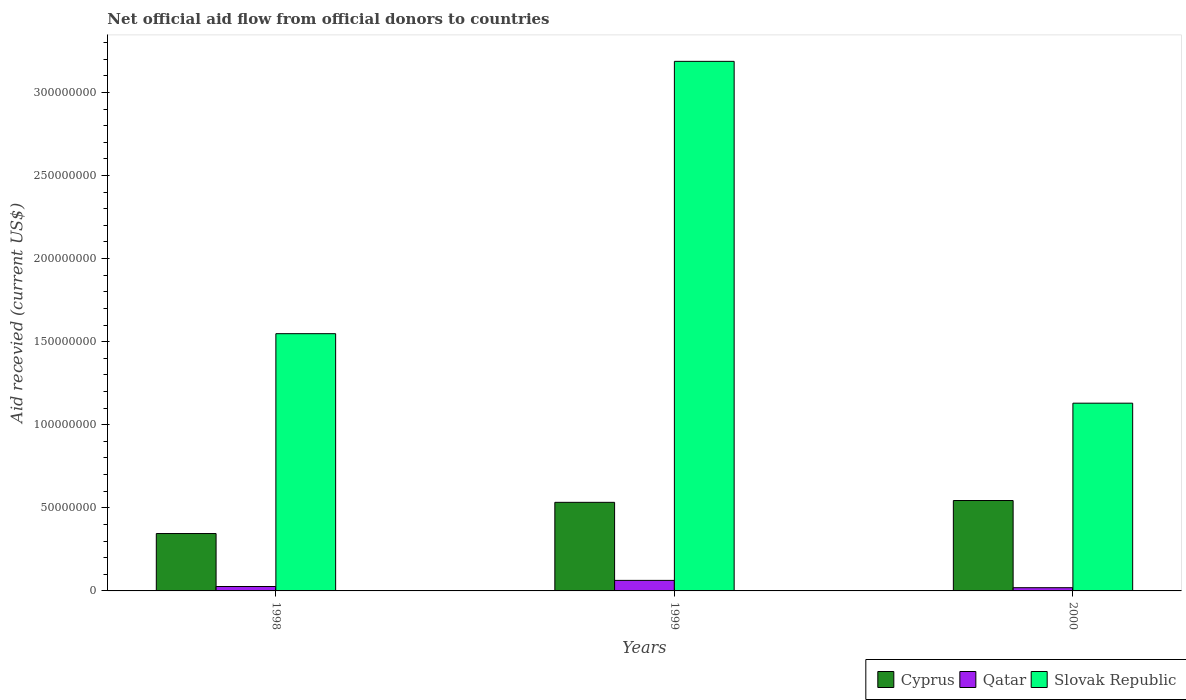Are the number of bars per tick equal to the number of legend labels?
Your answer should be compact. Yes. How many bars are there on the 2nd tick from the left?
Keep it short and to the point. 3. How many bars are there on the 2nd tick from the right?
Provide a succinct answer. 3. In how many cases, is the number of bars for a given year not equal to the number of legend labels?
Keep it short and to the point. 0. What is the total aid received in Slovak Republic in 2000?
Your answer should be very brief. 1.13e+08. Across all years, what is the maximum total aid received in Qatar?
Keep it short and to the point. 6.34e+06. Across all years, what is the minimum total aid received in Qatar?
Keep it short and to the point. 1.94e+06. In which year was the total aid received in Qatar maximum?
Provide a succinct answer. 1999. In which year was the total aid received in Slovak Republic minimum?
Offer a terse response. 2000. What is the total total aid received in Slovak Republic in the graph?
Ensure brevity in your answer.  5.87e+08. What is the difference between the total aid received in Cyprus in 1998 and that in 1999?
Your response must be concise. -1.88e+07. What is the difference between the total aid received in Cyprus in 2000 and the total aid received in Slovak Republic in 1999?
Your answer should be compact. -2.64e+08. What is the average total aid received in Qatar per year?
Your answer should be very brief. 3.65e+06. In the year 2000, what is the difference between the total aid received in Slovak Republic and total aid received in Cyprus?
Ensure brevity in your answer.  5.86e+07. In how many years, is the total aid received in Cyprus greater than 70000000 US$?
Ensure brevity in your answer.  0. What is the ratio of the total aid received in Slovak Republic in 1999 to that in 2000?
Offer a very short reply. 2.82. Is the total aid received in Qatar in 1999 less than that in 2000?
Offer a very short reply. No. What is the difference between the highest and the second highest total aid received in Slovak Republic?
Keep it short and to the point. 1.64e+08. What is the difference between the highest and the lowest total aid received in Qatar?
Make the answer very short. 4.40e+06. In how many years, is the total aid received in Slovak Republic greater than the average total aid received in Slovak Republic taken over all years?
Provide a short and direct response. 1. What does the 1st bar from the left in 1998 represents?
Ensure brevity in your answer.  Cyprus. What does the 1st bar from the right in 2000 represents?
Your answer should be very brief. Slovak Republic. Is it the case that in every year, the sum of the total aid received in Qatar and total aid received in Slovak Republic is greater than the total aid received in Cyprus?
Your response must be concise. Yes. How many bars are there?
Ensure brevity in your answer.  9. Where does the legend appear in the graph?
Your response must be concise. Bottom right. How many legend labels are there?
Provide a short and direct response. 3. How are the legend labels stacked?
Your response must be concise. Horizontal. What is the title of the graph?
Your response must be concise. Net official aid flow from official donors to countries. Does "San Marino" appear as one of the legend labels in the graph?
Offer a very short reply. No. What is the label or title of the Y-axis?
Your answer should be very brief. Aid recevied (current US$). What is the Aid recevied (current US$) in Cyprus in 1998?
Keep it short and to the point. 3.45e+07. What is the Aid recevied (current US$) of Qatar in 1998?
Give a very brief answer. 2.66e+06. What is the Aid recevied (current US$) of Slovak Republic in 1998?
Provide a succinct answer. 1.55e+08. What is the Aid recevied (current US$) in Cyprus in 1999?
Keep it short and to the point. 5.33e+07. What is the Aid recevied (current US$) in Qatar in 1999?
Keep it short and to the point. 6.34e+06. What is the Aid recevied (current US$) of Slovak Republic in 1999?
Make the answer very short. 3.19e+08. What is the Aid recevied (current US$) of Cyprus in 2000?
Give a very brief answer. 5.44e+07. What is the Aid recevied (current US$) of Qatar in 2000?
Provide a succinct answer. 1.94e+06. What is the Aid recevied (current US$) in Slovak Republic in 2000?
Provide a succinct answer. 1.13e+08. Across all years, what is the maximum Aid recevied (current US$) of Cyprus?
Keep it short and to the point. 5.44e+07. Across all years, what is the maximum Aid recevied (current US$) of Qatar?
Your answer should be very brief. 6.34e+06. Across all years, what is the maximum Aid recevied (current US$) of Slovak Republic?
Offer a terse response. 3.19e+08. Across all years, what is the minimum Aid recevied (current US$) in Cyprus?
Give a very brief answer. 3.45e+07. Across all years, what is the minimum Aid recevied (current US$) of Qatar?
Provide a short and direct response. 1.94e+06. Across all years, what is the minimum Aid recevied (current US$) in Slovak Republic?
Your response must be concise. 1.13e+08. What is the total Aid recevied (current US$) of Cyprus in the graph?
Your response must be concise. 1.42e+08. What is the total Aid recevied (current US$) of Qatar in the graph?
Your answer should be compact. 1.09e+07. What is the total Aid recevied (current US$) of Slovak Republic in the graph?
Offer a terse response. 5.87e+08. What is the difference between the Aid recevied (current US$) of Cyprus in 1998 and that in 1999?
Provide a short and direct response. -1.88e+07. What is the difference between the Aid recevied (current US$) in Qatar in 1998 and that in 1999?
Provide a succinct answer. -3.68e+06. What is the difference between the Aid recevied (current US$) of Slovak Republic in 1998 and that in 1999?
Offer a very short reply. -1.64e+08. What is the difference between the Aid recevied (current US$) in Cyprus in 1998 and that in 2000?
Provide a short and direct response. -1.99e+07. What is the difference between the Aid recevied (current US$) in Qatar in 1998 and that in 2000?
Give a very brief answer. 7.20e+05. What is the difference between the Aid recevied (current US$) in Slovak Republic in 1998 and that in 2000?
Your response must be concise. 4.18e+07. What is the difference between the Aid recevied (current US$) of Cyprus in 1999 and that in 2000?
Ensure brevity in your answer.  -1.09e+06. What is the difference between the Aid recevied (current US$) of Qatar in 1999 and that in 2000?
Your response must be concise. 4.40e+06. What is the difference between the Aid recevied (current US$) in Slovak Republic in 1999 and that in 2000?
Ensure brevity in your answer.  2.06e+08. What is the difference between the Aid recevied (current US$) of Cyprus in 1998 and the Aid recevied (current US$) of Qatar in 1999?
Give a very brief answer. 2.82e+07. What is the difference between the Aid recevied (current US$) in Cyprus in 1998 and the Aid recevied (current US$) in Slovak Republic in 1999?
Offer a very short reply. -2.84e+08. What is the difference between the Aid recevied (current US$) in Qatar in 1998 and the Aid recevied (current US$) in Slovak Republic in 1999?
Make the answer very short. -3.16e+08. What is the difference between the Aid recevied (current US$) of Cyprus in 1998 and the Aid recevied (current US$) of Qatar in 2000?
Your answer should be very brief. 3.26e+07. What is the difference between the Aid recevied (current US$) in Cyprus in 1998 and the Aid recevied (current US$) in Slovak Republic in 2000?
Ensure brevity in your answer.  -7.85e+07. What is the difference between the Aid recevied (current US$) in Qatar in 1998 and the Aid recevied (current US$) in Slovak Republic in 2000?
Give a very brief answer. -1.10e+08. What is the difference between the Aid recevied (current US$) in Cyprus in 1999 and the Aid recevied (current US$) in Qatar in 2000?
Offer a very short reply. 5.14e+07. What is the difference between the Aid recevied (current US$) of Cyprus in 1999 and the Aid recevied (current US$) of Slovak Republic in 2000?
Provide a succinct answer. -5.97e+07. What is the difference between the Aid recevied (current US$) of Qatar in 1999 and the Aid recevied (current US$) of Slovak Republic in 2000?
Provide a succinct answer. -1.07e+08. What is the average Aid recevied (current US$) in Cyprus per year?
Offer a very short reply. 4.74e+07. What is the average Aid recevied (current US$) of Qatar per year?
Provide a short and direct response. 3.65e+06. What is the average Aid recevied (current US$) of Slovak Republic per year?
Ensure brevity in your answer.  1.96e+08. In the year 1998, what is the difference between the Aid recevied (current US$) in Cyprus and Aid recevied (current US$) in Qatar?
Your answer should be very brief. 3.19e+07. In the year 1998, what is the difference between the Aid recevied (current US$) in Cyprus and Aid recevied (current US$) in Slovak Republic?
Keep it short and to the point. -1.20e+08. In the year 1998, what is the difference between the Aid recevied (current US$) in Qatar and Aid recevied (current US$) in Slovak Republic?
Provide a short and direct response. -1.52e+08. In the year 1999, what is the difference between the Aid recevied (current US$) in Cyprus and Aid recevied (current US$) in Qatar?
Make the answer very short. 4.70e+07. In the year 1999, what is the difference between the Aid recevied (current US$) of Cyprus and Aid recevied (current US$) of Slovak Republic?
Offer a terse response. -2.65e+08. In the year 1999, what is the difference between the Aid recevied (current US$) of Qatar and Aid recevied (current US$) of Slovak Republic?
Provide a short and direct response. -3.12e+08. In the year 2000, what is the difference between the Aid recevied (current US$) of Cyprus and Aid recevied (current US$) of Qatar?
Ensure brevity in your answer.  5.25e+07. In the year 2000, what is the difference between the Aid recevied (current US$) in Cyprus and Aid recevied (current US$) in Slovak Republic?
Ensure brevity in your answer.  -5.86e+07. In the year 2000, what is the difference between the Aid recevied (current US$) of Qatar and Aid recevied (current US$) of Slovak Republic?
Offer a terse response. -1.11e+08. What is the ratio of the Aid recevied (current US$) of Cyprus in 1998 to that in 1999?
Keep it short and to the point. 0.65. What is the ratio of the Aid recevied (current US$) of Qatar in 1998 to that in 1999?
Offer a very short reply. 0.42. What is the ratio of the Aid recevied (current US$) of Slovak Republic in 1998 to that in 1999?
Make the answer very short. 0.49. What is the ratio of the Aid recevied (current US$) in Cyprus in 1998 to that in 2000?
Keep it short and to the point. 0.63. What is the ratio of the Aid recevied (current US$) of Qatar in 1998 to that in 2000?
Keep it short and to the point. 1.37. What is the ratio of the Aid recevied (current US$) in Slovak Republic in 1998 to that in 2000?
Offer a very short reply. 1.37. What is the ratio of the Aid recevied (current US$) of Qatar in 1999 to that in 2000?
Give a very brief answer. 3.27. What is the ratio of the Aid recevied (current US$) of Slovak Republic in 1999 to that in 2000?
Keep it short and to the point. 2.82. What is the difference between the highest and the second highest Aid recevied (current US$) of Cyprus?
Make the answer very short. 1.09e+06. What is the difference between the highest and the second highest Aid recevied (current US$) in Qatar?
Your answer should be very brief. 3.68e+06. What is the difference between the highest and the second highest Aid recevied (current US$) of Slovak Republic?
Ensure brevity in your answer.  1.64e+08. What is the difference between the highest and the lowest Aid recevied (current US$) in Cyprus?
Give a very brief answer. 1.99e+07. What is the difference between the highest and the lowest Aid recevied (current US$) in Qatar?
Your answer should be very brief. 4.40e+06. What is the difference between the highest and the lowest Aid recevied (current US$) in Slovak Republic?
Your response must be concise. 2.06e+08. 